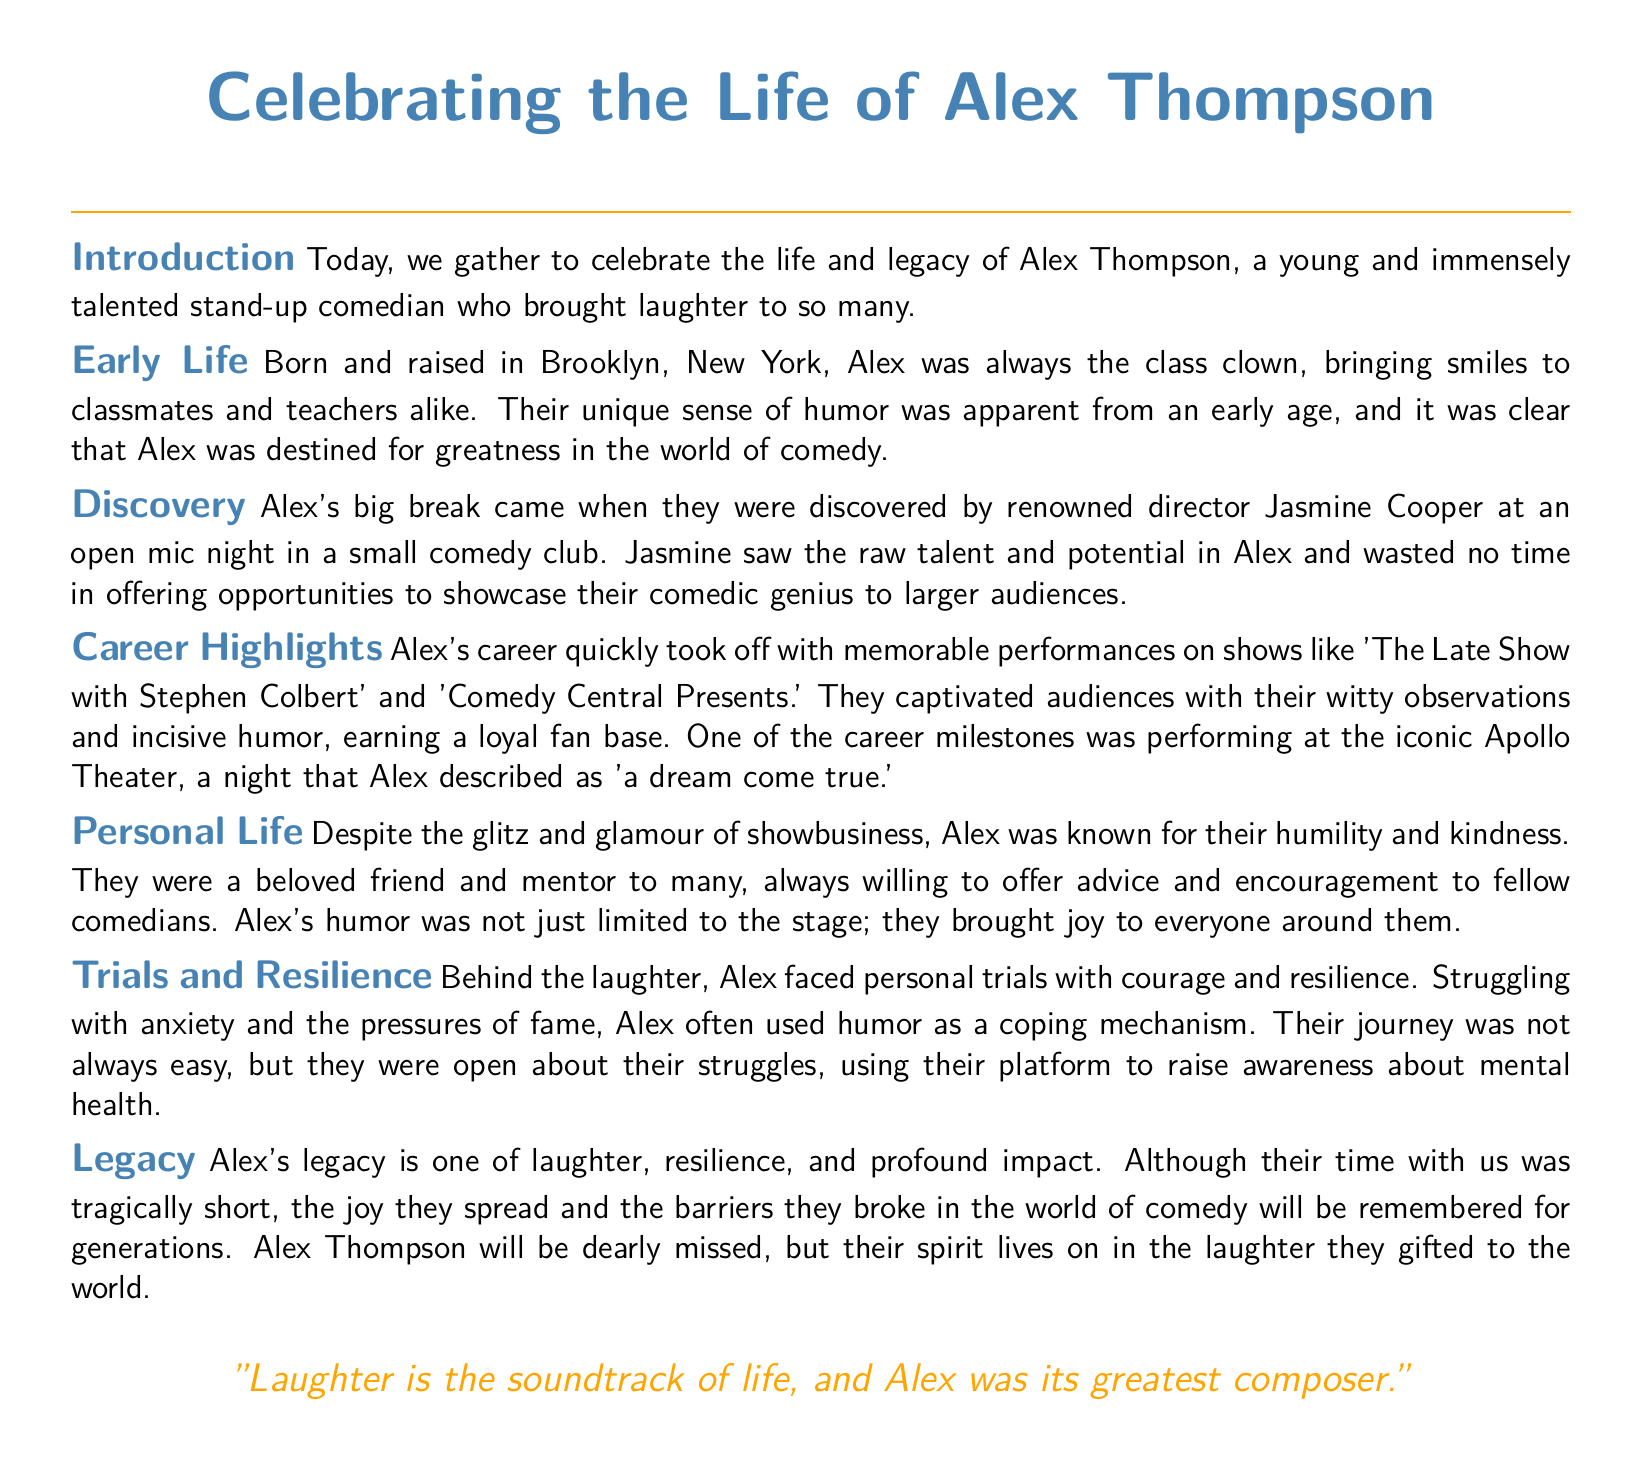What is the name of the comedian being celebrated? The document is a eulogy for Alex Thompson, who is highlighted throughout the text.
Answer: Alex Thompson Where was Alex born and raised? The early life section specifies that Alex was born and raised in Brooklyn, New York.
Answer: Brooklyn, New York Who discovered Alex's talent? The document mentions that renowned director Jasmine Cooper discovered Alex at an open mic night.
Answer: Jasmine Cooper What was one memorable performance venue for Alex? The career highlights section states that Alex performed at the iconic Apollo Theater, a significant milestone in their career.
Answer: Apollo Theater What did Alex often struggle with? The trials and resilience section discusses Alex facing struggles with anxiety and the pressures of fame.
Answer: Anxiety What impact did Alex have on fellow comedians? Alex was known as a beloved friend and mentor, offering advice and encouragement to many in the comedy community.
Answer: Mentor What is a quote mentioned in the eulogy? The conclusion of the document includes a quote that describes Alex's contribution to life through laughter.
Answer: "Laughter is the soundtrack of life, and Alex was its greatest composer." What type of humor did Alex use to cope with personal trials? The trials and resilience section states Alex used humor as a coping mechanism for their struggles.
Answer: Humor 